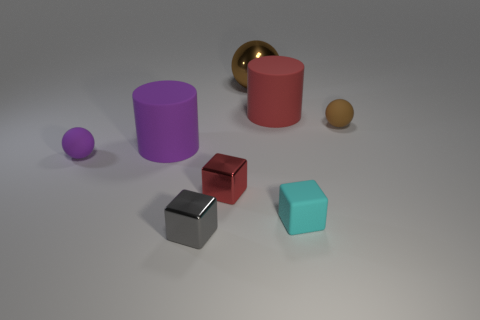Can you describe the lighting in the scene and how it affects the appearance of the objects? The scene is illuminated by a soft, diffuse light source, likely coming from above, casting subtle shadows beneath the objects. This type of lighting minimizes harsh shadows, allowing the intrinsic colors and shapes of the objects to be easily distinguishable without strong contrast. 